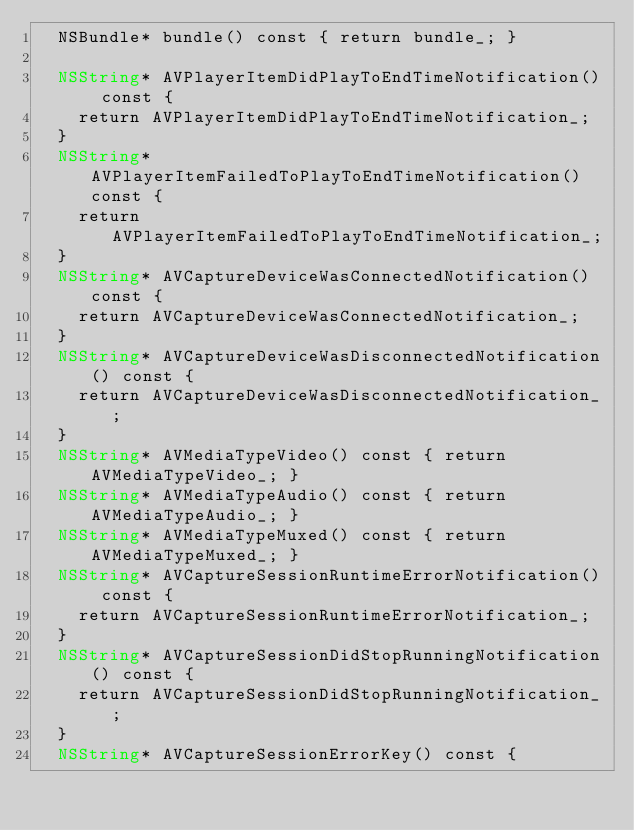<code> <loc_0><loc_0><loc_500><loc_500><_ObjectiveC_>  NSBundle* bundle() const { return bundle_; }

  NSString* AVPlayerItemDidPlayToEndTimeNotification() const {
    return AVPlayerItemDidPlayToEndTimeNotification_;
  }
  NSString* AVPlayerItemFailedToPlayToEndTimeNotification() const {
    return AVPlayerItemFailedToPlayToEndTimeNotification_;
  }
  NSString* AVCaptureDeviceWasConnectedNotification() const {
    return AVCaptureDeviceWasConnectedNotification_;
  }
  NSString* AVCaptureDeviceWasDisconnectedNotification() const {
    return AVCaptureDeviceWasDisconnectedNotification_;
  }
  NSString* AVMediaTypeVideo() const { return AVMediaTypeVideo_; }
  NSString* AVMediaTypeAudio() const { return AVMediaTypeAudio_; }
  NSString* AVMediaTypeMuxed() const { return AVMediaTypeMuxed_; }
  NSString* AVCaptureSessionRuntimeErrorNotification() const {
    return AVCaptureSessionRuntimeErrorNotification_;
  }
  NSString* AVCaptureSessionDidStopRunningNotification() const {
    return AVCaptureSessionDidStopRunningNotification_;
  }
  NSString* AVCaptureSessionErrorKey() const {</code> 